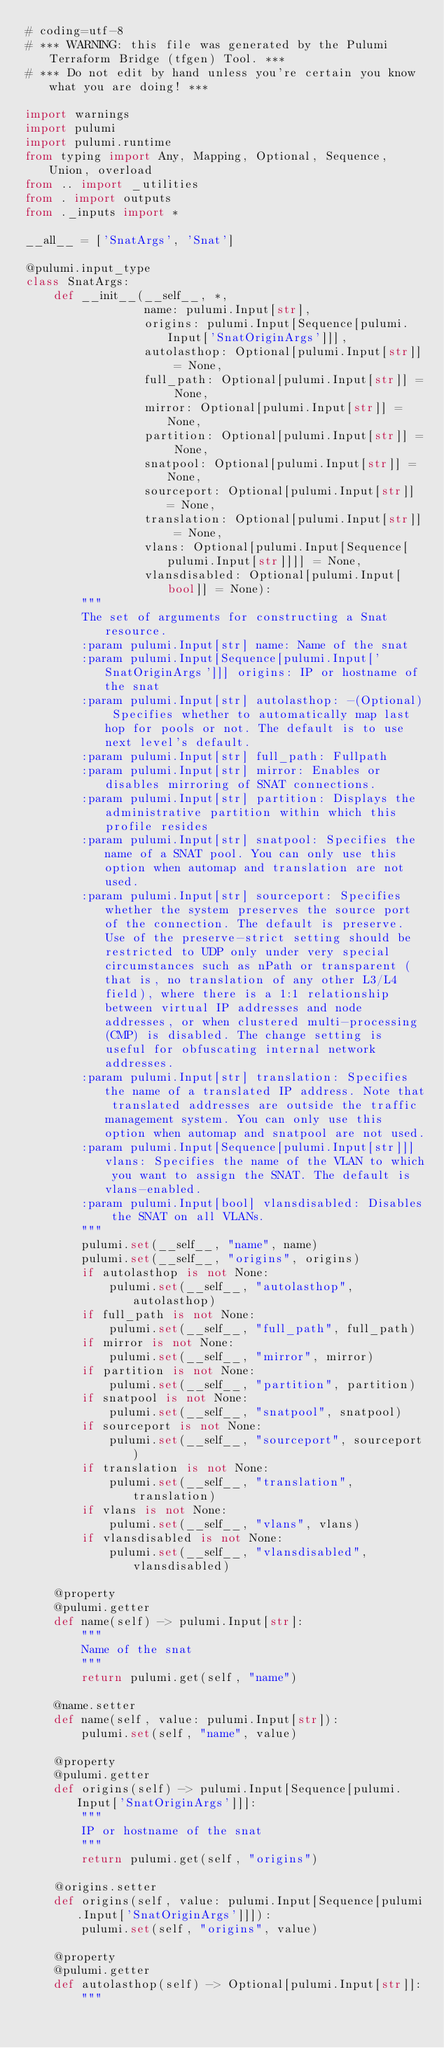Convert code to text. <code><loc_0><loc_0><loc_500><loc_500><_Python_># coding=utf-8
# *** WARNING: this file was generated by the Pulumi Terraform Bridge (tfgen) Tool. ***
# *** Do not edit by hand unless you're certain you know what you are doing! ***

import warnings
import pulumi
import pulumi.runtime
from typing import Any, Mapping, Optional, Sequence, Union, overload
from .. import _utilities
from . import outputs
from ._inputs import *

__all__ = ['SnatArgs', 'Snat']

@pulumi.input_type
class SnatArgs:
    def __init__(__self__, *,
                 name: pulumi.Input[str],
                 origins: pulumi.Input[Sequence[pulumi.Input['SnatOriginArgs']]],
                 autolasthop: Optional[pulumi.Input[str]] = None,
                 full_path: Optional[pulumi.Input[str]] = None,
                 mirror: Optional[pulumi.Input[str]] = None,
                 partition: Optional[pulumi.Input[str]] = None,
                 snatpool: Optional[pulumi.Input[str]] = None,
                 sourceport: Optional[pulumi.Input[str]] = None,
                 translation: Optional[pulumi.Input[str]] = None,
                 vlans: Optional[pulumi.Input[Sequence[pulumi.Input[str]]]] = None,
                 vlansdisabled: Optional[pulumi.Input[bool]] = None):
        """
        The set of arguments for constructing a Snat resource.
        :param pulumi.Input[str] name: Name of the snat
        :param pulumi.Input[Sequence[pulumi.Input['SnatOriginArgs']]] origins: IP or hostname of the snat
        :param pulumi.Input[str] autolasthop: -(Optional) Specifies whether to automatically map last hop for pools or not. The default is to use next level's default.
        :param pulumi.Input[str] full_path: Fullpath
        :param pulumi.Input[str] mirror: Enables or disables mirroring of SNAT connections.
        :param pulumi.Input[str] partition: Displays the administrative partition within which this profile resides
        :param pulumi.Input[str] snatpool: Specifies the name of a SNAT pool. You can only use this option when automap and translation are not used.
        :param pulumi.Input[str] sourceport: Specifies whether the system preserves the source port of the connection. The default is preserve. Use of the preserve-strict setting should be restricted to UDP only under very special circumstances such as nPath or transparent (that is, no translation of any other L3/L4 field), where there is a 1:1 relationship between virtual IP addresses and node addresses, or when clustered multi-processing (CMP) is disabled. The change setting is useful for obfuscating internal network addresses.
        :param pulumi.Input[str] translation: Specifies the name of a translated IP address. Note that translated addresses are outside the traffic management system. You can only use this option when automap and snatpool are not used.
        :param pulumi.Input[Sequence[pulumi.Input[str]]] vlans: Specifies the name of the VLAN to which you want to assign the SNAT. The default is vlans-enabled.
        :param pulumi.Input[bool] vlansdisabled: Disables the SNAT on all VLANs.
        """
        pulumi.set(__self__, "name", name)
        pulumi.set(__self__, "origins", origins)
        if autolasthop is not None:
            pulumi.set(__self__, "autolasthop", autolasthop)
        if full_path is not None:
            pulumi.set(__self__, "full_path", full_path)
        if mirror is not None:
            pulumi.set(__self__, "mirror", mirror)
        if partition is not None:
            pulumi.set(__self__, "partition", partition)
        if snatpool is not None:
            pulumi.set(__self__, "snatpool", snatpool)
        if sourceport is not None:
            pulumi.set(__self__, "sourceport", sourceport)
        if translation is not None:
            pulumi.set(__self__, "translation", translation)
        if vlans is not None:
            pulumi.set(__self__, "vlans", vlans)
        if vlansdisabled is not None:
            pulumi.set(__self__, "vlansdisabled", vlansdisabled)

    @property
    @pulumi.getter
    def name(self) -> pulumi.Input[str]:
        """
        Name of the snat
        """
        return pulumi.get(self, "name")

    @name.setter
    def name(self, value: pulumi.Input[str]):
        pulumi.set(self, "name", value)

    @property
    @pulumi.getter
    def origins(self) -> pulumi.Input[Sequence[pulumi.Input['SnatOriginArgs']]]:
        """
        IP or hostname of the snat
        """
        return pulumi.get(self, "origins")

    @origins.setter
    def origins(self, value: pulumi.Input[Sequence[pulumi.Input['SnatOriginArgs']]]):
        pulumi.set(self, "origins", value)

    @property
    @pulumi.getter
    def autolasthop(self) -> Optional[pulumi.Input[str]]:
        """</code> 